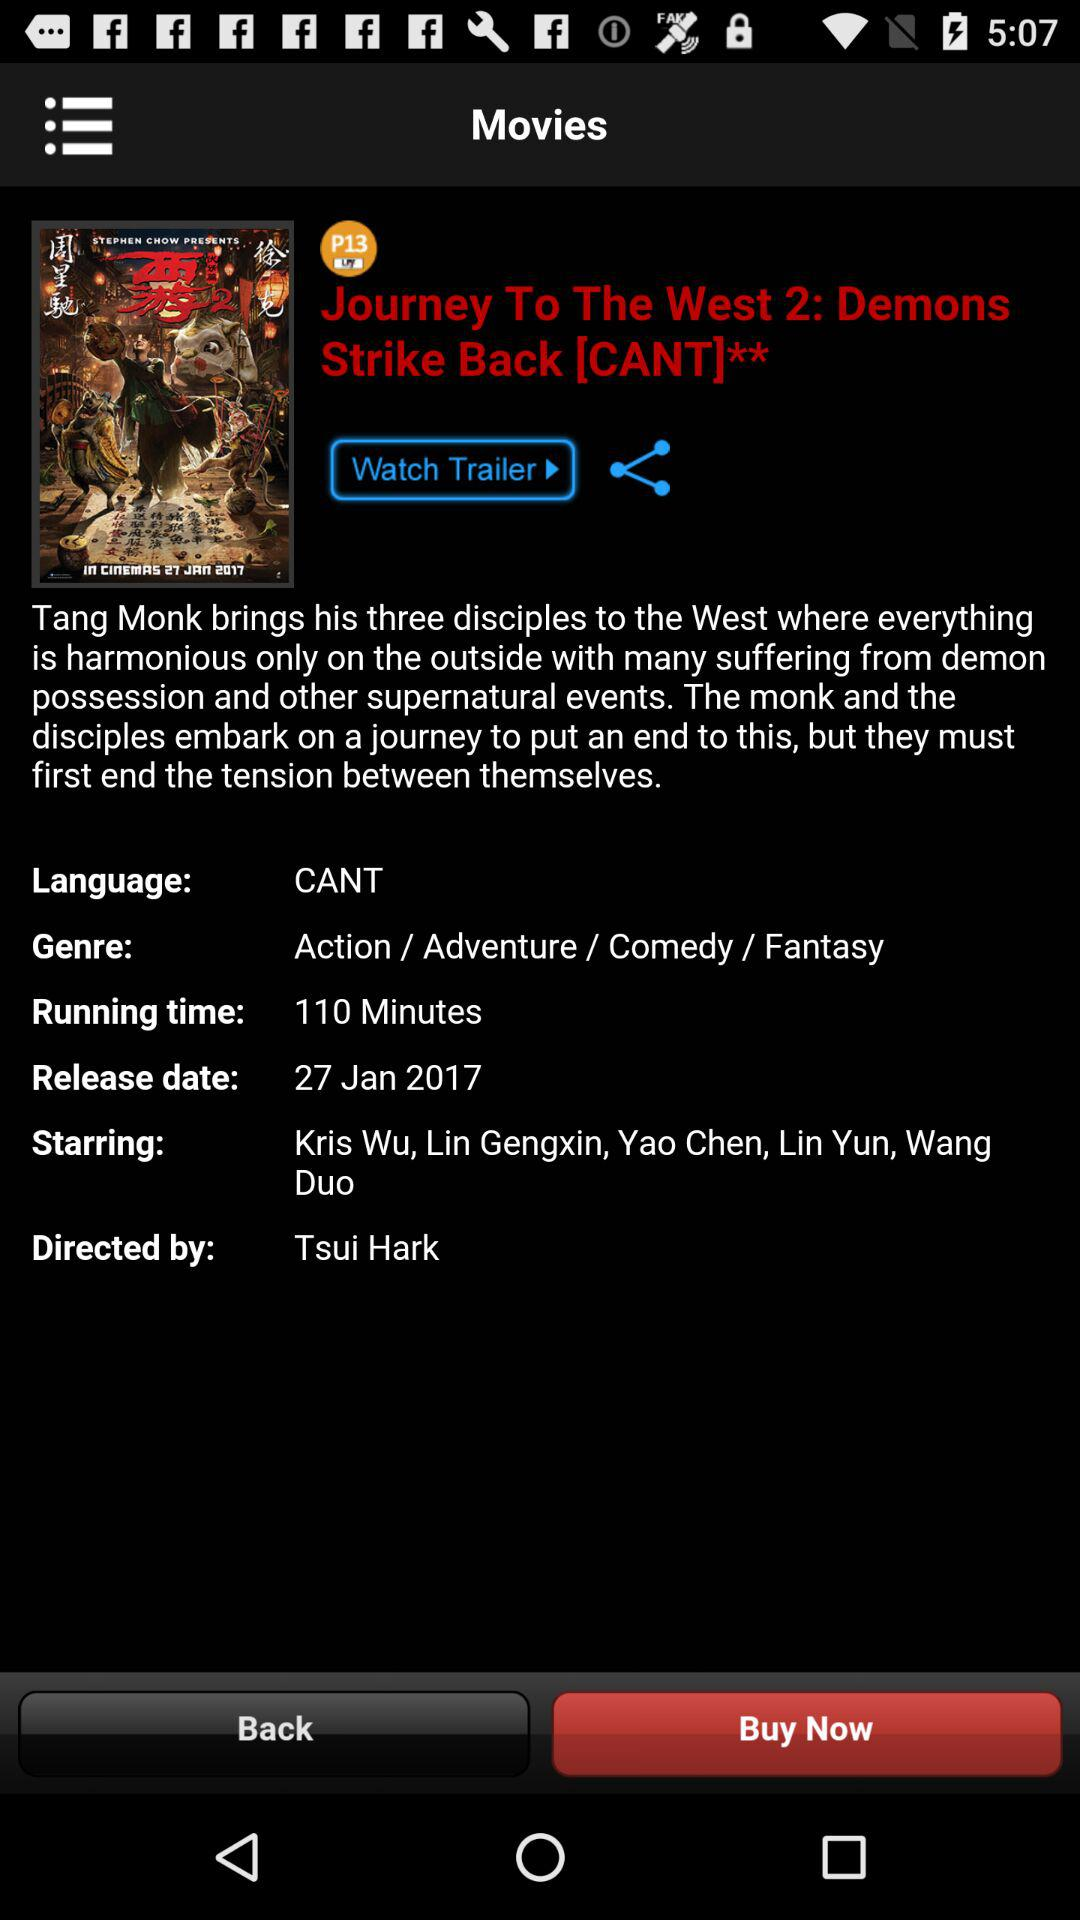Who's the director of the movie? The director of the movie is Tsui Hark. 